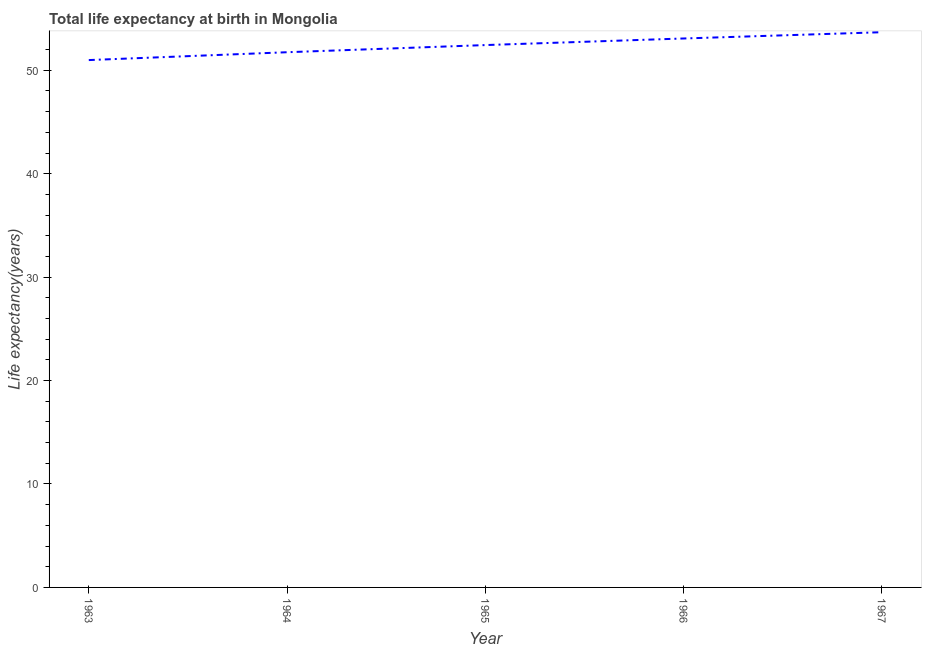What is the life expectancy at birth in 1963?
Give a very brief answer. 50.99. Across all years, what is the maximum life expectancy at birth?
Make the answer very short. 53.68. Across all years, what is the minimum life expectancy at birth?
Provide a short and direct response. 50.99. In which year was the life expectancy at birth maximum?
Make the answer very short. 1967. In which year was the life expectancy at birth minimum?
Ensure brevity in your answer.  1963. What is the sum of the life expectancy at birth?
Give a very brief answer. 261.93. What is the difference between the life expectancy at birth in 1963 and 1964?
Your response must be concise. -0.76. What is the average life expectancy at birth per year?
Your response must be concise. 52.39. What is the median life expectancy at birth?
Your response must be concise. 52.44. In how many years, is the life expectancy at birth greater than 36 years?
Offer a terse response. 5. Do a majority of the years between 1966 and 1964 (inclusive) have life expectancy at birth greater than 24 years?
Ensure brevity in your answer.  No. What is the ratio of the life expectancy at birth in 1966 to that in 1967?
Keep it short and to the point. 0.99. Is the life expectancy at birth in 1965 less than that in 1966?
Provide a short and direct response. Yes. Is the difference between the life expectancy at birth in 1965 and 1967 greater than the difference between any two years?
Keep it short and to the point. No. What is the difference between the highest and the second highest life expectancy at birth?
Your response must be concise. 0.61. Is the sum of the life expectancy at birth in 1963 and 1966 greater than the maximum life expectancy at birth across all years?
Your answer should be compact. Yes. What is the difference between the highest and the lowest life expectancy at birth?
Provide a succinct answer. 2.69. How many lines are there?
Provide a short and direct response. 1. How many years are there in the graph?
Offer a very short reply. 5. What is the difference between two consecutive major ticks on the Y-axis?
Provide a short and direct response. 10. Does the graph contain any zero values?
Your response must be concise. No. What is the title of the graph?
Your answer should be compact. Total life expectancy at birth in Mongolia. What is the label or title of the Y-axis?
Make the answer very short. Life expectancy(years). What is the Life expectancy(years) of 1963?
Provide a succinct answer. 50.99. What is the Life expectancy(years) in 1964?
Offer a very short reply. 51.75. What is the Life expectancy(years) of 1965?
Offer a very short reply. 52.44. What is the Life expectancy(years) of 1966?
Provide a short and direct response. 53.08. What is the Life expectancy(years) in 1967?
Your response must be concise. 53.68. What is the difference between the Life expectancy(years) in 1963 and 1964?
Ensure brevity in your answer.  -0.76. What is the difference between the Life expectancy(years) in 1963 and 1965?
Keep it short and to the point. -1.45. What is the difference between the Life expectancy(years) in 1963 and 1966?
Provide a short and direct response. -2.09. What is the difference between the Life expectancy(years) in 1963 and 1967?
Your answer should be compact. -2.69. What is the difference between the Life expectancy(years) in 1964 and 1965?
Give a very brief answer. -0.69. What is the difference between the Life expectancy(years) in 1964 and 1966?
Your response must be concise. -1.33. What is the difference between the Life expectancy(years) in 1964 and 1967?
Your answer should be very brief. -1.93. What is the difference between the Life expectancy(years) in 1965 and 1966?
Provide a short and direct response. -0.64. What is the difference between the Life expectancy(years) in 1965 and 1967?
Your answer should be very brief. -1.24. What is the difference between the Life expectancy(years) in 1966 and 1967?
Offer a very short reply. -0.61. What is the ratio of the Life expectancy(years) in 1963 to that in 1966?
Your answer should be compact. 0.96. What is the ratio of the Life expectancy(years) in 1964 to that in 1967?
Give a very brief answer. 0.96. What is the ratio of the Life expectancy(years) in 1965 to that in 1967?
Provide a short and direct response. 0.98. 